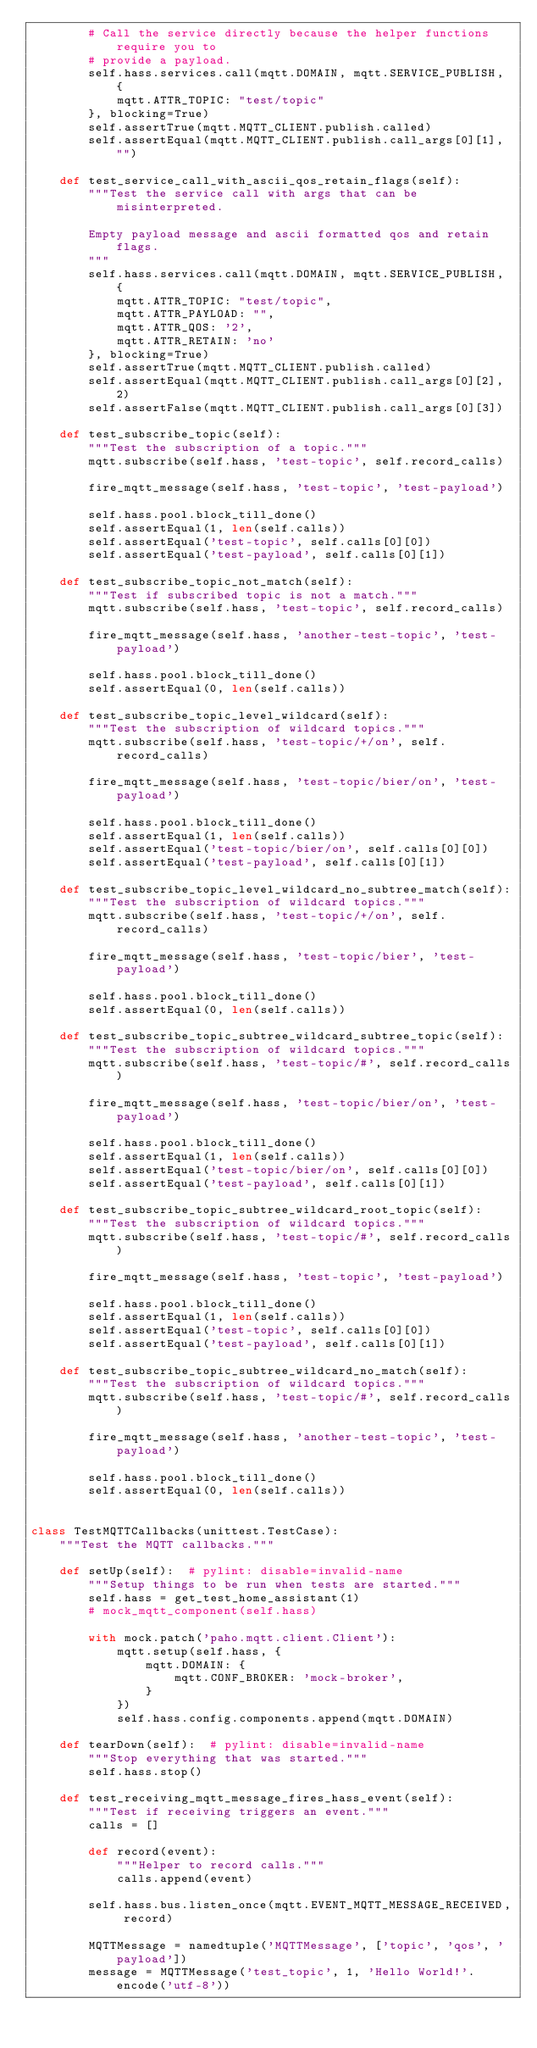Convert code to text. <code><loc_0><loc_0><loc_500><loc_500><_Python_>        # Call the service directly because the helper functions require you to
        # provide a payload.
        self.hass.services.call(mqtt.DOMAIN, mqtt.SERVICE_PUBLISH, {
            mqtt.ATTR_TOPIC: "test/topic"
        }, blocking=True)
        self.assertTrue(mqtt.MQTT_CLIENT.publish.called)
        self.assertEqual(mqtt.MQTT_CLIENT.publish.call_args[0][1], "")

    def test_service_call_with_ascii_qos_retain_flags(self):
        """Test the service call with args that can be misinterpreted.

        Empty payload message and ascii formatted qos and retain flags.
        """
        self.hass.services.call(mqtt.DOMAIN, mqtt.SERVICE_PUBLISH, {
            mqtt.ATTR_TOPIC: "test/topic",
            mqtt.ATTR_PAYLOAD: "",
            mqtt.ATTR_QOS: '2',
            mqtt.ATTR_RETAIN: 'no'
        }, blocking=True)
        self.assertTrue(mqtt.MQTT_CLIENT.publish.called)
        self.assertEqual(mqtt.MQTT_CLIENT.publish.call_args[0][2], 2)
        self.assertFalse(mqtt.MQTT_CLIENT.publish.call_args[0][3])

    def test_subscribe_topic(self):
        """Test the subscription of a topic."""
        mqtt.subscribe(self.hass, 'test-topic', self.record_calls)

        fire_mqtt_message(self.hass, 'test-topic', 'test-payload')

        self.hass.pool.block_till_done()
        self.assertEqual(1, len(self.calls))
        self.assertEqual('test-topic', self.calls[0][0])
        self.assertEqual('test-payload', self.calls[0][1])

    def test_subscribe_topic_not_match(self):
        """Test if subscribed topic is not a match."""
        mqtt.subscribe(self.hass, 'test-topic', self.record_calls)

        fire_mqtt_message(self.hass, 'another-test-topic', 'test-payload')

        self.hass.pool.block_till_done()
        self.assertEqual(0, len(self.calls))

    def test_subscribe_topic_level_wildcard(self):
        """Test the subscription of wildcard topics."""
        mqtt.subscribe(self.hass, 'test-topic/+/on', self.record_calls)

        fire_mqtt_message(self.hass, 'test-topic/bier/on', 'test-payload')

        self.hass.pool.block_till_done()
        self.assertEqual(1, len(self.calls))
        self.assertEqual('test-topic/bier/on', self.calls[0][0])
        self.assertEqual('test-payload', self.calls[0][1])

    def test_subscribe_topic_level_wildcard_no_subtree_match(self):
        """Test the subscription of wildcard topics."""
        mqtt.subscribe(self.hass, 'test-topic/+/on', self.record_calls)

        fire_mqtt_message(self.hass, 'test-topic/bier', 'test-payload')

        self.hass.pool.block_till_done()
        self.assertEqual(0, len(self.calls))

    def test_subscribe_topic_subtree_wildcard_subtree_topic(self):
        """Test the subscription of wildcard topics."""
        mqtt.subscribe(self.hass, 'test-topic/#', self.record_calls)

        fire_mqtt_message(self.hass, 'test-topic/bier/on', 'test-payload')

        self.hass.pool.block_till_done()
        self.assertEqual(1, len(self.calls))
        self.assertEqual('test-topic/bier/on', self.calls[0][0])
        self.assertEqual('test-payload', self.calls[0][1])

    def test_subscribe_topic_subtree_wildcard_root_topic(self):
        """Test the subscription of wildcard topics."""
        mqtt.subscribe(self.hass, 'test-topic/#', self.record_calls)

        fire_mqtt_message(self.hass, 'test-topic', 'test-payload')

        self.hass.pool.block_till_done()
        self.assertEqual(1, len(self.calls))
        self.assertEqual('test-topic', self.calls[0][0])
        self.assertEqual('test-payload', self.calls[0][1])

    def test_subscribe_topic_subtree_wildcard_no_match(self):
        """Test the subscription of wildcard topics."""
        mqtt.subscribe(self.hass, 'test-topic/#', self.record_calls)

        fire_mqtt_message(self.hass, 'another-test-topic', 'test-payload')

        self.hass.pool.block_till_done()
        self.assertEqual(0, len(self.calls))


class TestMQTTCallbacks(unittest.TestCase):
    """Test the MQTT callbacks."""

    def setUp(self):  # pylint: disable=invalid-name
        """Setup things to be run when tests are started."""
        self.hass = get_test_home_assistant(1)
        # mock_mqtt_component(self.hass)

        with mock.patch('paho.mqtt.client.Client'):
            mqtt.setup(self.hass, {
                mqtt.DOMAIN: {
                    mqtt.CONF_BROKER: 'mock-broker',
                }
            })
            self.hass.config.components.append(mqtt.DOMAIN)

    def tearDown(self):  # pylint: disable=invalid-name
        """Stop everything that was started."""
        self.hass.stop()

    def test_receiving_mqtt_message_fires_hass_event(self):
        """Test if receiving triggers an event."""
        calls = []

        def record(event):
            """Helper to record calls."""
            calls.append(event)

        self.hass.bus.listen_once(mqtt.EVENT_MQTT_MESSAGE_RECEIVED, record)

        MQTTMessage = namedtuple('MQTTMessage', ['topic', 'qos', 'payload'])
        message = MQTTMessage('test_topic', 1, 'Hello World!'.encode('utf-8'))
</code> 